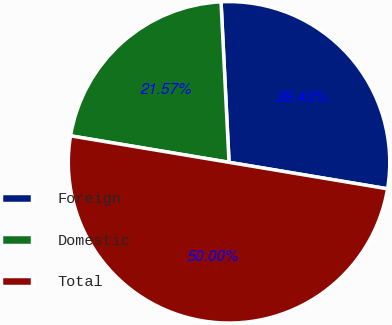<chart> <loc_0><loc_0><loc_500><loc_500><pie_chart><fcel>Foreign<fcel>Domestic<fcel>Total<nl><fcel>28.43%<fcel>21.57%<fcel>50.0%<nl></chart> 